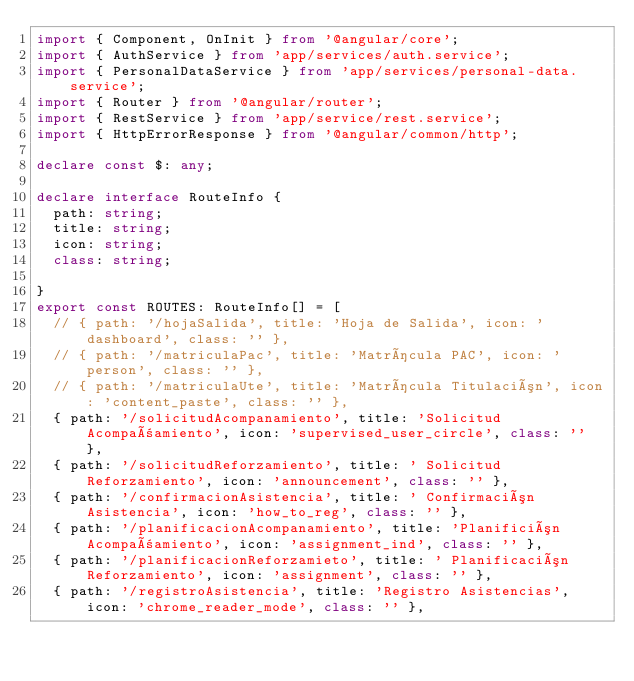Convert code to text. <code><loc_0><loc_0><loc_500><loc_500><_TypeScript_>import { Component, OnInit } from '@angular/core';
import { AuthService } from 'app/services/auth.service';
import { PersonalDataService } from 'app/services/personal-data.service';
import { Router } from '@angular/router';
import { RestService } from 'app/service/rest.service';
import { HttpErrorResponse } from '@angular/common/http';

declare const $: any;

declare interface RouteInfo {
  path: string;
  title: string;
  icon: string;
  class: string;

}
export const ROUTES: RouteInfo[] = [
  // { path: '/hojaSalida', title: 'Hoja de Salida', icon: 'dashboard', class: '' },
  // { path: '/matriculaPac', title: 'Matrícula PAC', icon: 'person', class: '' },
  // { path: '/matriculaUte', title: 'Matrícula Titulación', icon: 'content_paste', class: '' },
  { path: '/solicitudAcompanamiento', title: 'Solicitud Acompañamiento', icon: 'supervised_user_circle', class: '' },
  { path: '/solicitudReforzamiento', title: ' Solicitud Reforzamiento', icon: 'announcement', class: '' },
  { path: '/confirmacionAsistencia', title: ' Confirmación Asistencia', icon: 'how_to_reg', class: '' },
  { path: '/planificacionAcompanamiento', title: 'Planifición Acompañamiento', icon: 'assignment_ind', class: '' },
  { path: '/planificacionReforzamieto', title: ' Planificación Reforzamiento', icon: 'assignment', class: '' },
  { path: '/registroAsistencia', title: 'Registro Asistencias', icon: 'chrome_reader_mode', class: '' },</code> 